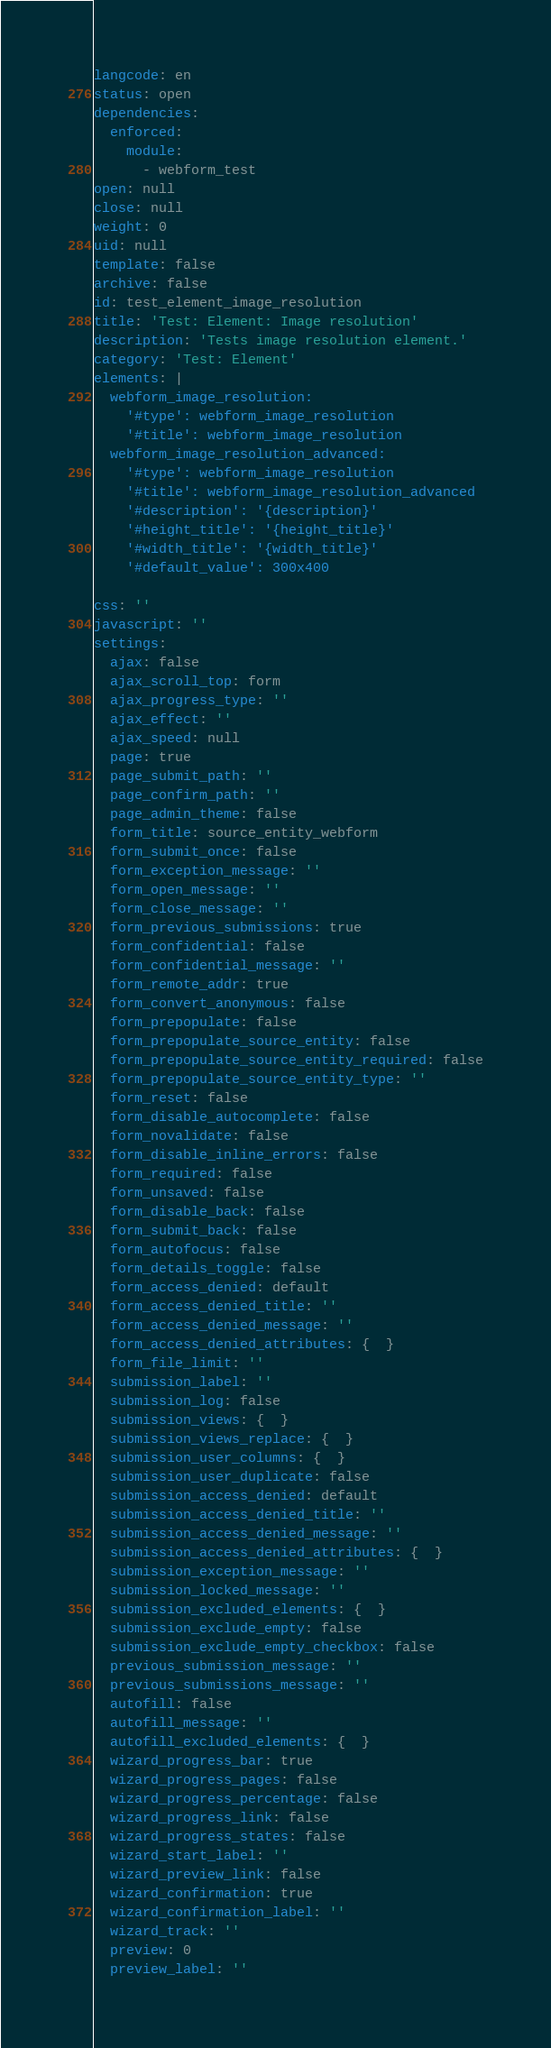<code> <loc_0><loc_0><loc_500><loc_500><_YAML_>langcode: en
status: open
dependencies:
  enforced:
    module:
      - webform_test
open: null
close: null
weight: 0
uid: null
template: false
archive: false
id: test_element_image_resolution
title: 'Test: Element: Image resolution'
description: 'Tests image resolution element.'
category: 'Test: Element'
elements: |
  webform_image_resolution:
    '#type': webform_image_resolution
    '#title': webform_image_resolution
  webform_image_resolution_advanced:
    '#type': webform_image_resolution
    '#title': webform_image_resolution_advanced
    '#description': '{description}'
    '#height_title': '{height_title}'
    '#width_title': '{width_title}'
    '#default_value': 300x400
  
css: ''
javascript: ''
settings:
  ajax: false
  ajax_scroll_top: form
  ajax_progress_type: ''
  ajax_effect: ''
  ajax_speed: null
  page: true
  page_submit_path: ''
  page_confirm_path: ''
  page_admin_theme: false
  form_title: source_entity_webform
  form_submit_once: false
  form_exception_message: ''
  form_open_message: ''
  form_close_message: ''
  form_previous_submissions: true
  form_confidential: false
  form_confidential_message: ''
  form_remote_addr: true
  form_convert_anonymous: false
  form_prepopulate: false
  form_prepopulate_source_entity: false
  form_prepopulate_source_entity_required: false
  form_prepopulate_source_entity_type: ''
  form_reset: false
  form_disable_autocomplete: false
  form_novalidate: false
  form_disable_inline_errors: false
  form_required: false
  form_unsaved: false
  form_disable_back: false
  form_submit_back: false
  form_autofocus: false
  form_details_toggle: false
  form_access_denied: default
  form_access_denied_title: ''
  form_access_denied_message: ''
  form_access_denied_attributes: {  }
  form_file_limit: ''
  submission_label: ''
  submission_log: false
  submission_views: {  }
  submission_views_replace: {  }
  submission_user_columns: {  }
  submission_user_duplicate: false
  submission_access_denied: default
  submission_access_denied_title: ''
  submission_access_denied_message: ''
  submission_access_denied_attributes: {  }
  submission_exception_message: ''
  submission_locked_message: ''
  submission_excluded_elements: {  }
  submission_exclude_empty: false
  submission_exclude_empty_checkbox: false
  previous_submission_message: ''
  previous_submissions_message: ''
  autofill: false
  autofill_message: ''
  autofill_excluded_elements: {  }
  wizard_progress_bar: true
  wizard_progress_pages: false
  wizard_progress_percentage: false
  wizard_progress_link: false
  wizard_progress_states: false
  wizard_start_label: ''
  wizard_preview_link: false
  wizard_confirmation: true
  wizard_confirmation_label: ''
  wizard_track: ''
  preview: 0
  preview_label: ''</code> 